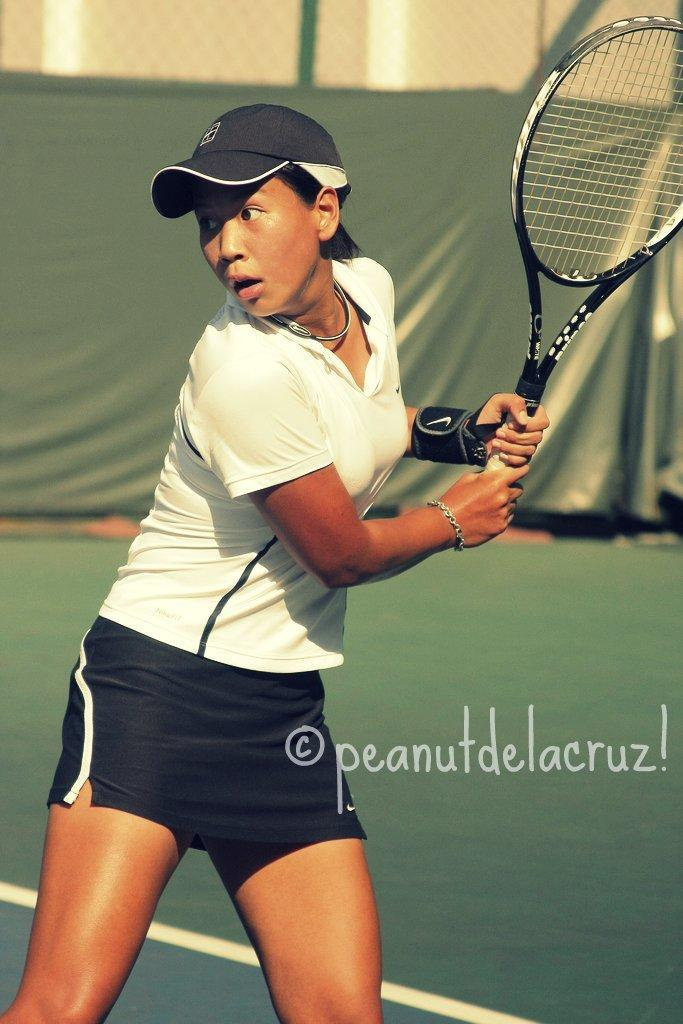What activity is the person in the image engaged in? The person in the image is a badminton player. What equipment is the badminton player holding? The badminton player is holding a bat. What is the color of the carpet in the image? The carpet in the image is green. What separates the two sides of the badminton court in the image? There is a net in the image. What type of window treatment is present in the image? There is a green color curtain at the back side in the image. What type of quill is the badminton player using to write their name on the badge in the image? There is no quill or badge present in the image; the badminton player is holding a bat and there is a net and a green color curtain in the background. What color is the gold medal hanging around the badminton player's neck in the image? There is no gold medal or any medal present in the image. 